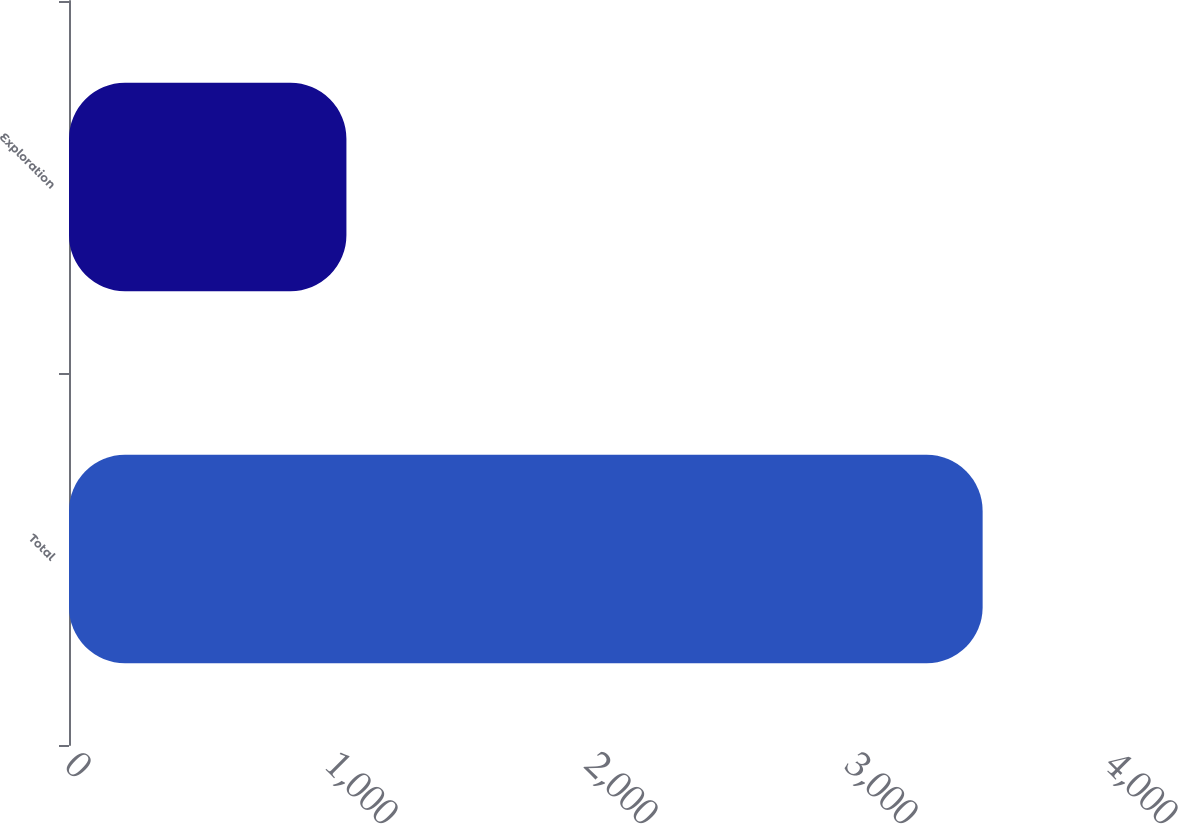Convert chart. <chart><loc_0><loc_0><loc_500><loc_500><bar_chart><fcel>Total<fcel>Exploration<nl><fcel>3514<fcel>1067<nl></chart> 